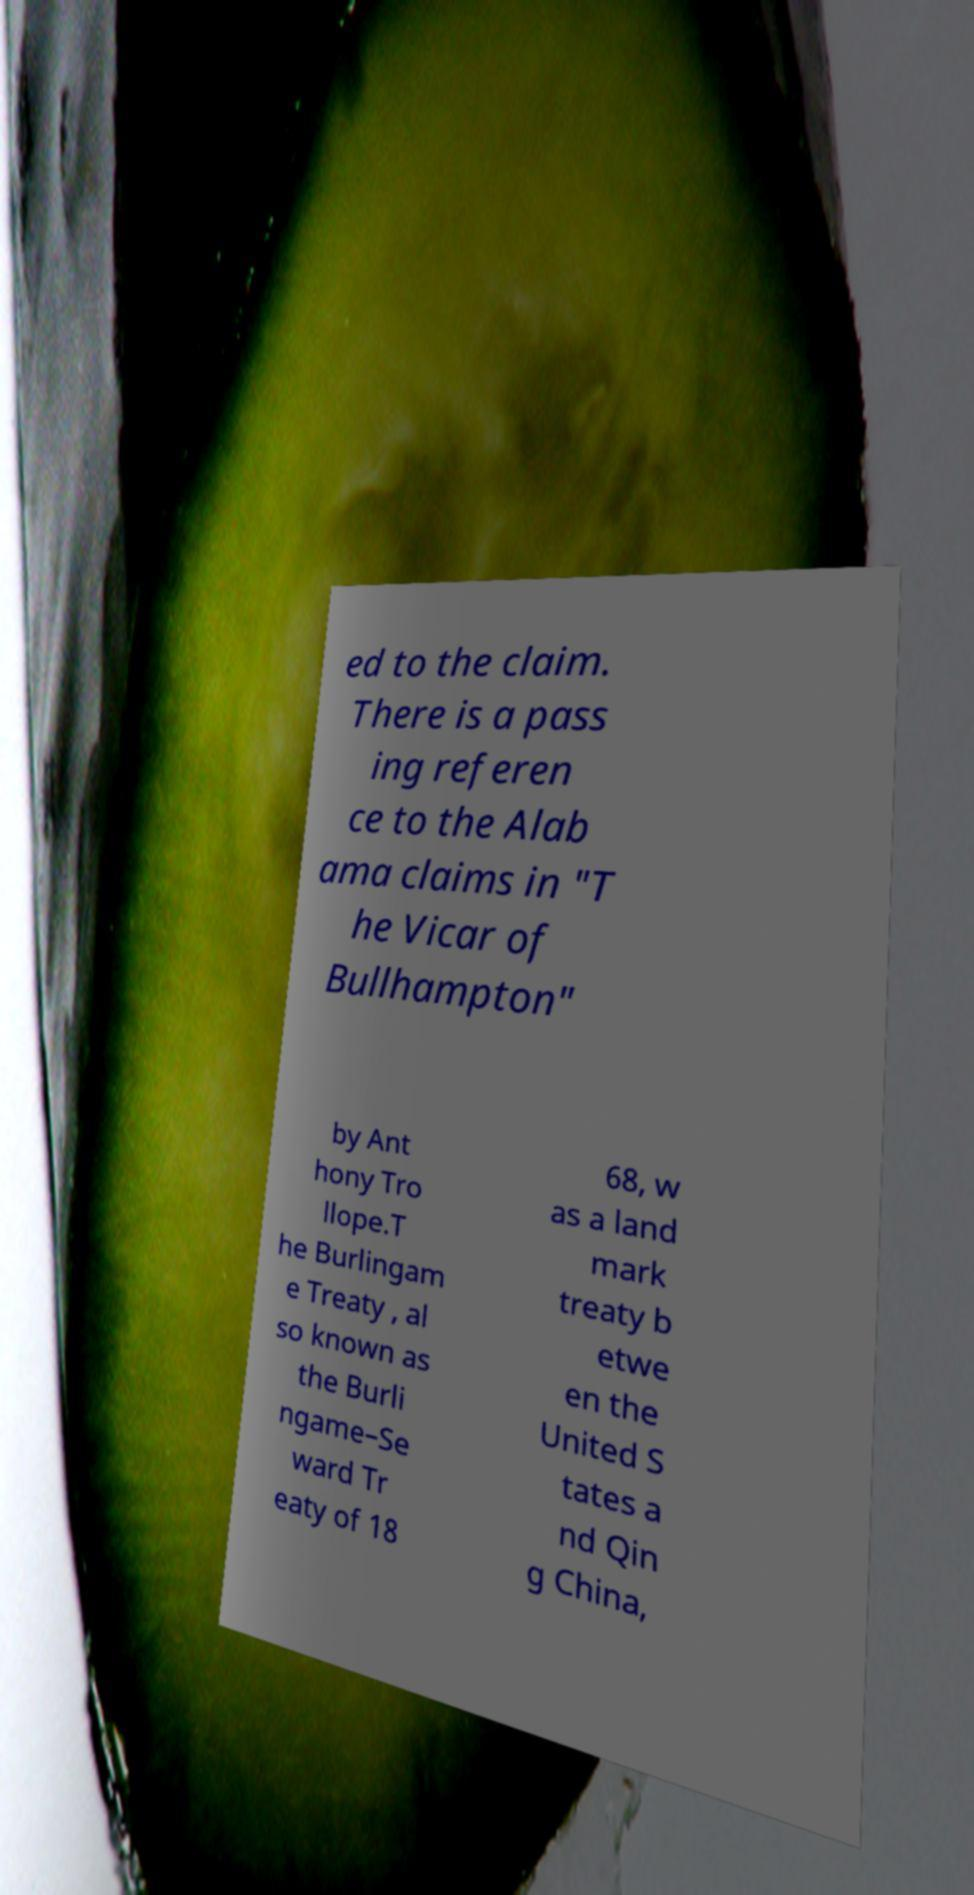There's text embedded in this image that I need extracted. Can you transcribe it verbatim? ed to the claim. There is a pass ing referen ce to the Alab ama claims in "T he Vicar of Bullhampton" by Ant hony Tro llope.T he Burlingam e Treaty , al so known as the Burli ngame–Se ward Tr eaty of 18 68, w as a land mark treaty b etwe en the United S tates a nd Qin g China, 